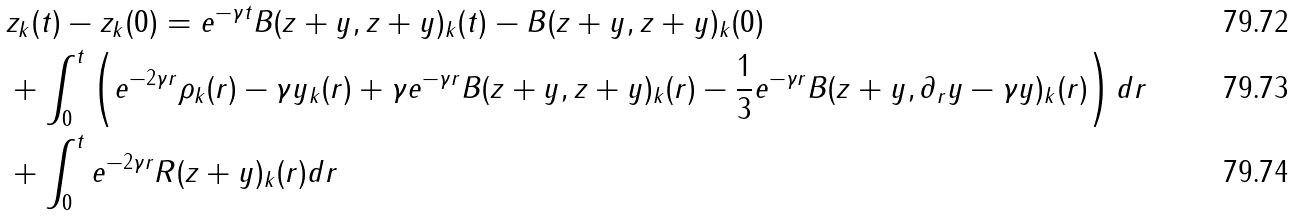Convert formula to latex. <formula><loc_0><loc_0><loc_500><loc_500>& z _ { k } ( t ) - z _ { k } ( 0 ) = e ^ { - \gamma t } B ( z + y , z + y ) _ { k } ( t ) - B ( z + y , z + y ) _ { k } ( 0 ) \\ & + \int _ { 0 } ^ { t } \left ( e ^ { - 2 \gamma r } \rho _ { k } ( r ) - \gamma y _ { k } ( r ) + \gamma e ^ { - \gamma r } B ( z + y , z + y ) _ { k } ( r ) - \frac { 1 } { 3 } e ^ { - \gamma r } B ( z + y , \partial _ { r } y - \gamma y ) _ { k } ( r ) \right ) d r \\ & + \int _ { 0 } ^ { t } e ^ { - 2 \gamma r } R ( z + y ) _ { k } ( r ) d r</formula> 